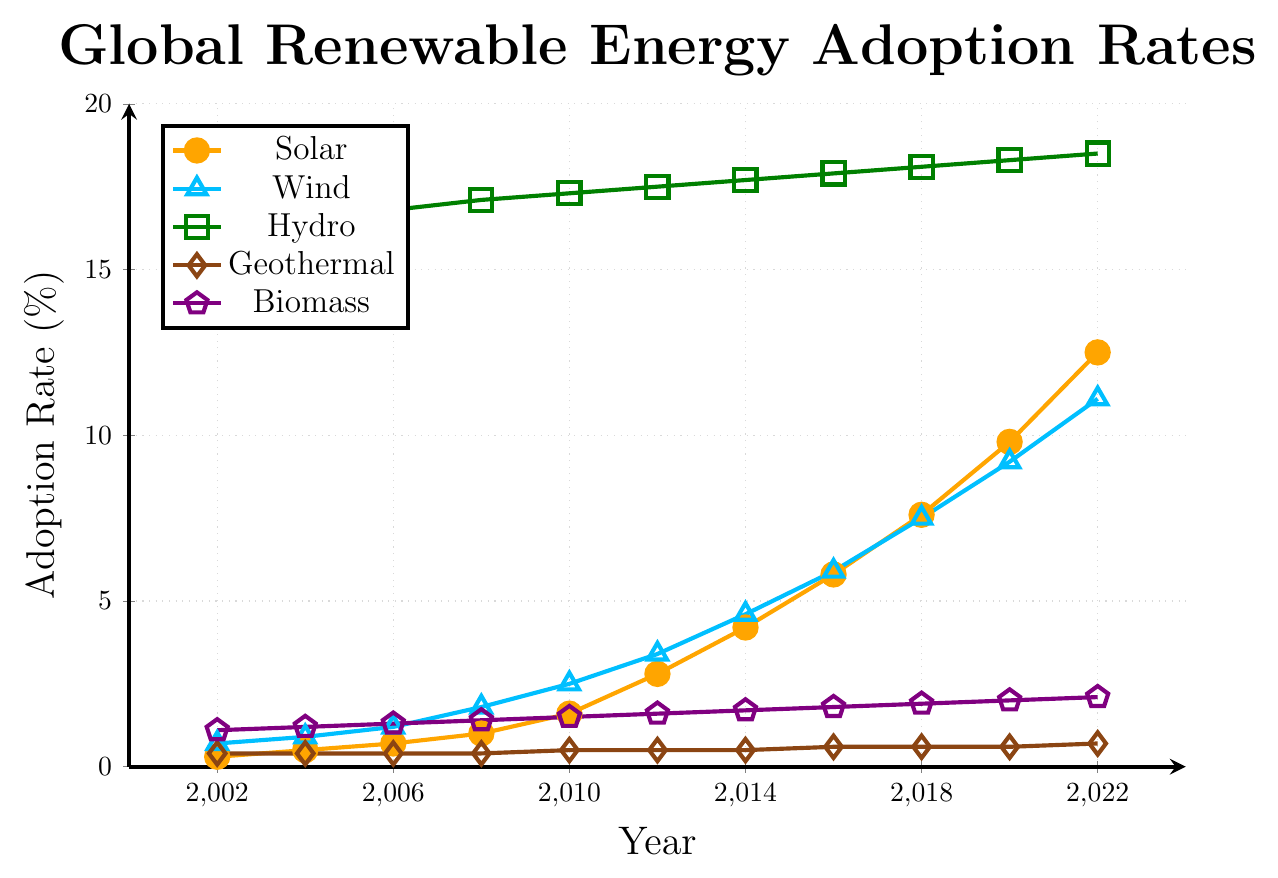What's the overall trend in solar energy adoption over the 20 years? The solar energy adoption rate has generally increased every year from 0.3% in 2002 to 12.5% in 2022.
Answer: Increasing Which energy source had the highest adoption rate in 2022? By examining the endpoints for each line, hydro had the highest adoption rate at 18.5% in 2022.
Answer: Hydro In which year did wind energy adoption surpass 5%? By tracing the wind energy line, it surpassed 5% between 2014 and 2016, specifically in 2016 when it reached 5.9%.
Answer: 2016 How much more did solar energy adoption grow compared to biomass energy from 2002 to 2022? Solar grew from 0.3% to 12.5% (an increase of 12.2%), while biomass grew from 1.1% to 2.1% (an increase of 1.0%). The difference in growth is 12.2% - 1.0% = 11.2%.
Answer: 11.2% Which energy source experienced the least growth over the 20 years? By comparing the endpoints, geothermal grew from 0.4% to 0.7%, an increase of 0.3%, which is the least among all sources.
Answer: Geothermal Which two renewable energy sources had the closest adoption rates in 2008? In 2008, geothermal and biomass both had close adoption rates. Geothermal was at 0.4%, and biomass was at 1.4%, with wind being at 1.8%. But geothermal and biomass have a difference of 1.0 percentage points, providing the smallest disparity.
Answer: Geothermal and Biomass How did the adoption rate of hydro energy change from 2010 to 2020? The hydro energy line shows an increase from 17.3% in 2010 to 18.3% in 2020, a change of 1.0%.
Answer: Increased by 1.0% What was the average adoption rate of wind energy from 2002 to 2022? Sum the wind energy adoption rates for each year: 0.7 + 0.9 + 1.2 + 1.8 + 2.5 + 3.4 + 4.6 + 5.9 + 7.5 + 9.2 + 11.1 = 48.8, then divide by the number of years (11): 48.8/11 ≈ 4.44%.
Answer: ≈ 4.44% Which energy source had the most significant percentage increase from 2002 to 2022? Calculate the percentage increase for each source. Solar increased from 0.3% to 12.5%, which is a (12.5 - 0.3)/0.3 * 100 ≈ 4067% increase. This is the largest compared to other sources.
Answer: Solar 